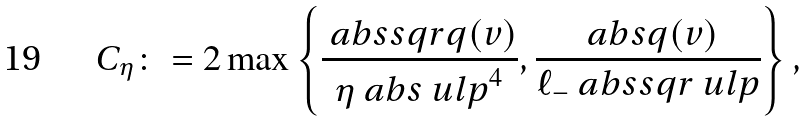Convert formula to latex. <formula><loc_0><loc_0><loc_500><loc_500>C _ { \eta } \colon = 2 \max \left \{ \frac { \ a b s s q r { q ( v ) } } { \eta \ a b s { \ u l p } ^ { 4 } } , \frac { \ a b s { q ( v ) } } { \ell _ { - } \ a b s s q r { \ u l p } } \right \} ,</formula> 